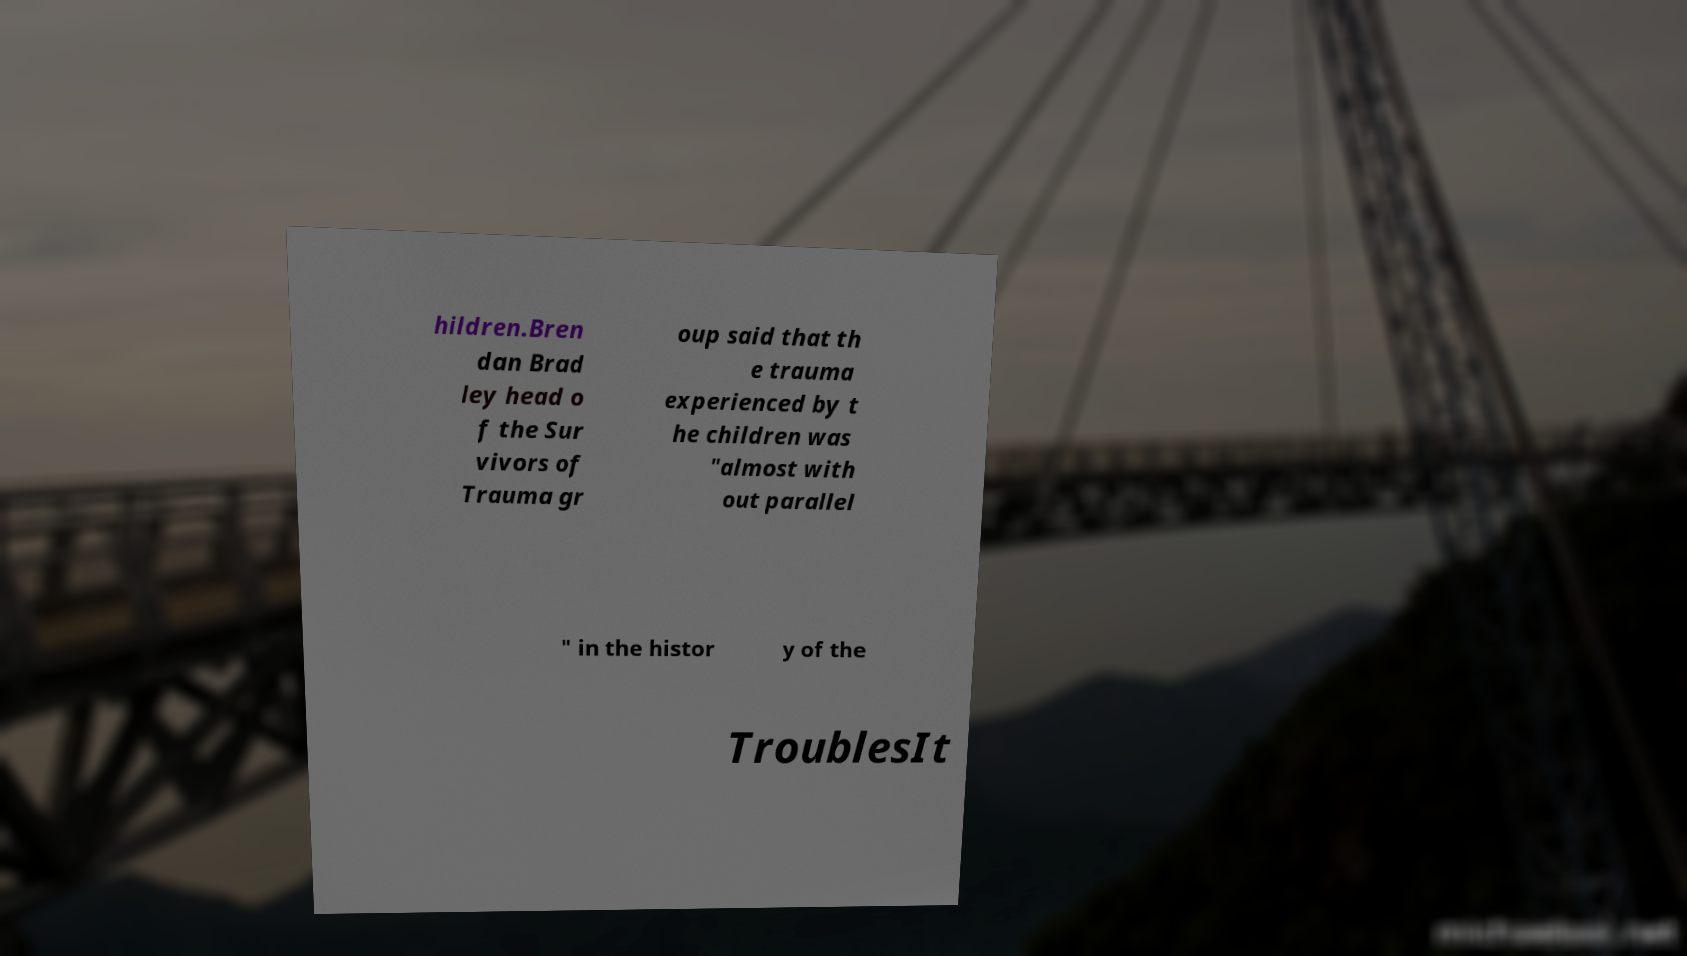Can you read and provide the text displayed in the image?This photo seems to have some interesting text. Can you extract and type it out for me? hildren.Bren dan Brad ley head o f the Sur vivors of Trauma gr oup said that th e trauma experienced by t he children was "almost with out parallel " in the histor y of the TroublesIt 